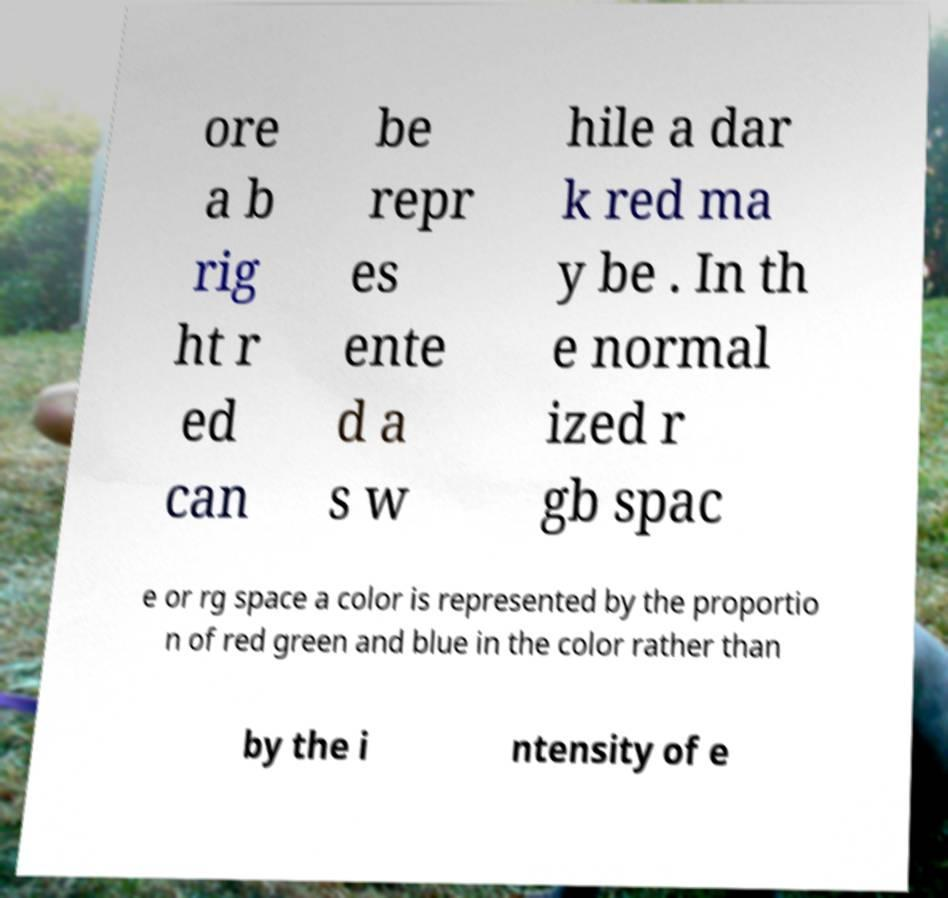Please read and relay the text visible in this image. What does it say? ore a b rig ht r ed can be repr es ente d a s w hile a dar k red ma y be . In th e normal ized r gb spac e or rg space a color is represented by the proportio n of red green and blue in the color rather than by the i ntensity of e 